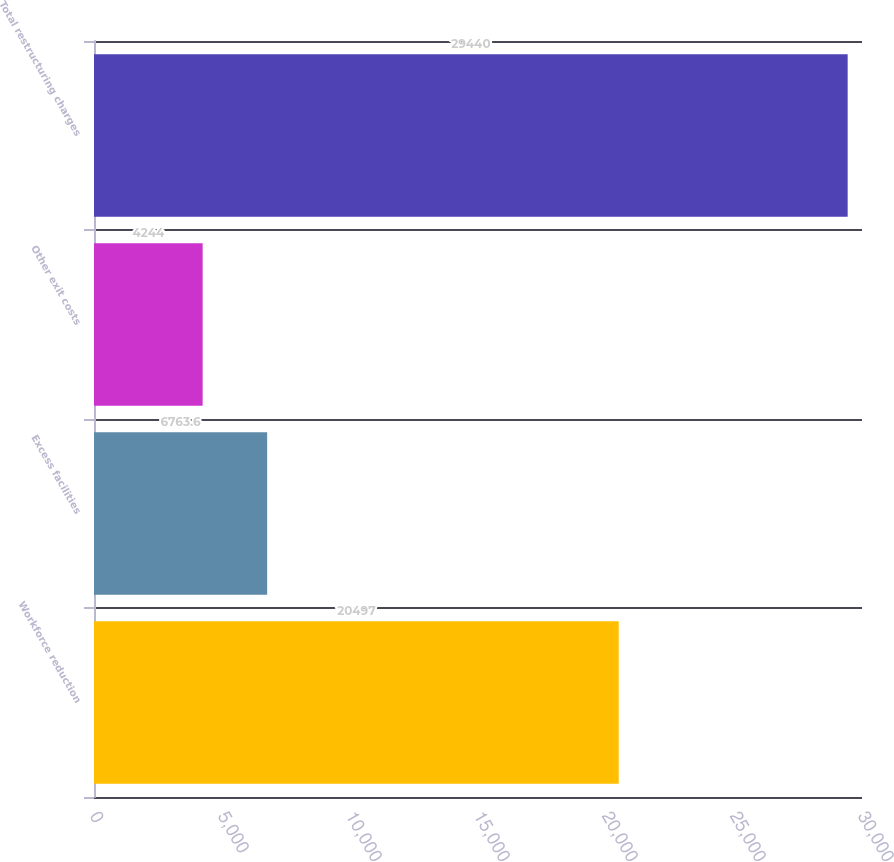Convert chart to OTSL. <chart><loc_0><loc_0><loc_500><loc_500><bar_chart><fcel>Workforce reduction<fcel>Excess facilities<fcel>Other exit costs<fcel>Total restructuring charges<nl><fcel>20497<fcel>6763.6<fcel>4244<fcel>29440<nl></chart> 